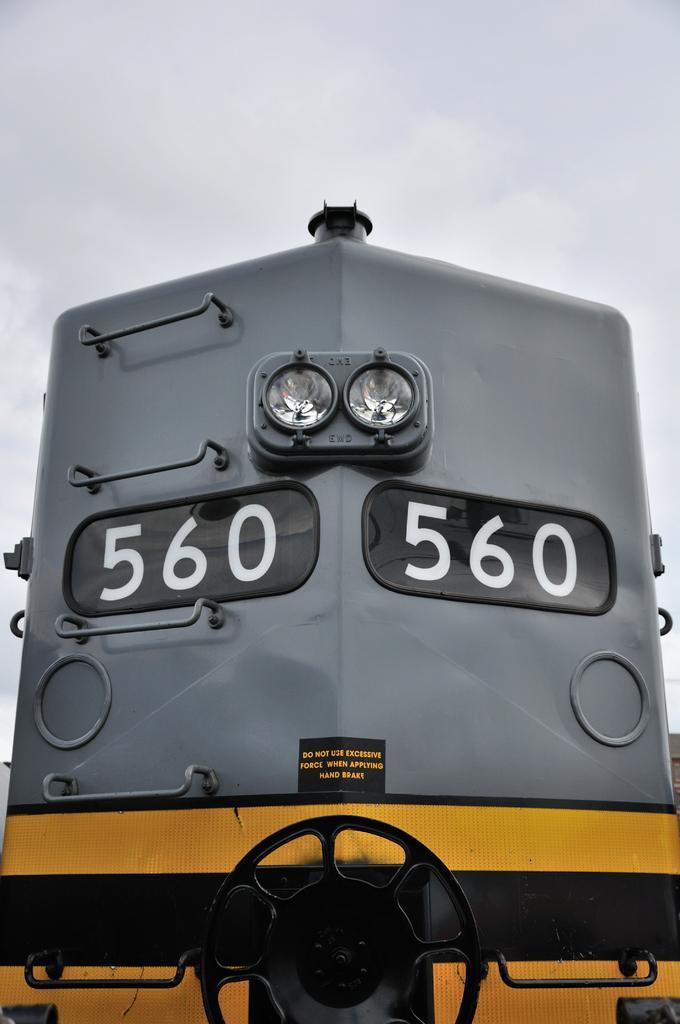Can you describe this image briefly? In this image we can see there is a train. In the background we can see the sky. 